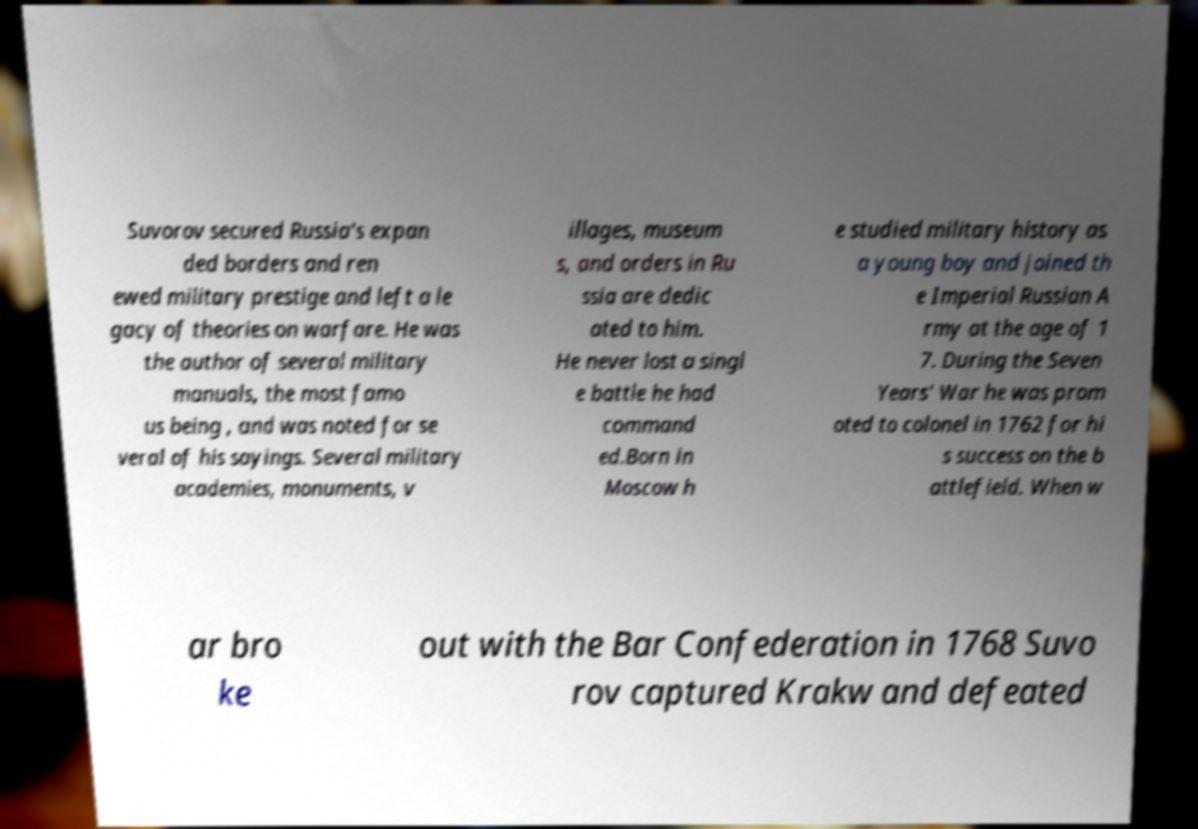Could you extract and type out the text from this image? Suvorov secured Russia's expan ded borders and ren ewed military prestige and left a le gacy of theories on warfare. He was the author of several military manuals, the most famo us being , and was noted for se veral of his sayings. Several military academies, monuments, v illages, museum s, and orders in Ru ssia are dedic ated to him. He never lost a singl e battle he had command ed.Born in Moscow h e studied military history as a young boy and joined th e Imperial Russian A rmy at the age of 1 7. During the Seven Years' War he was prom oted to colonel in 1762 for hi s success on the b attlefield. When w ar bro ke out with the Bar Confederation in 1768 Suvo rov captured Krakw and defeated 